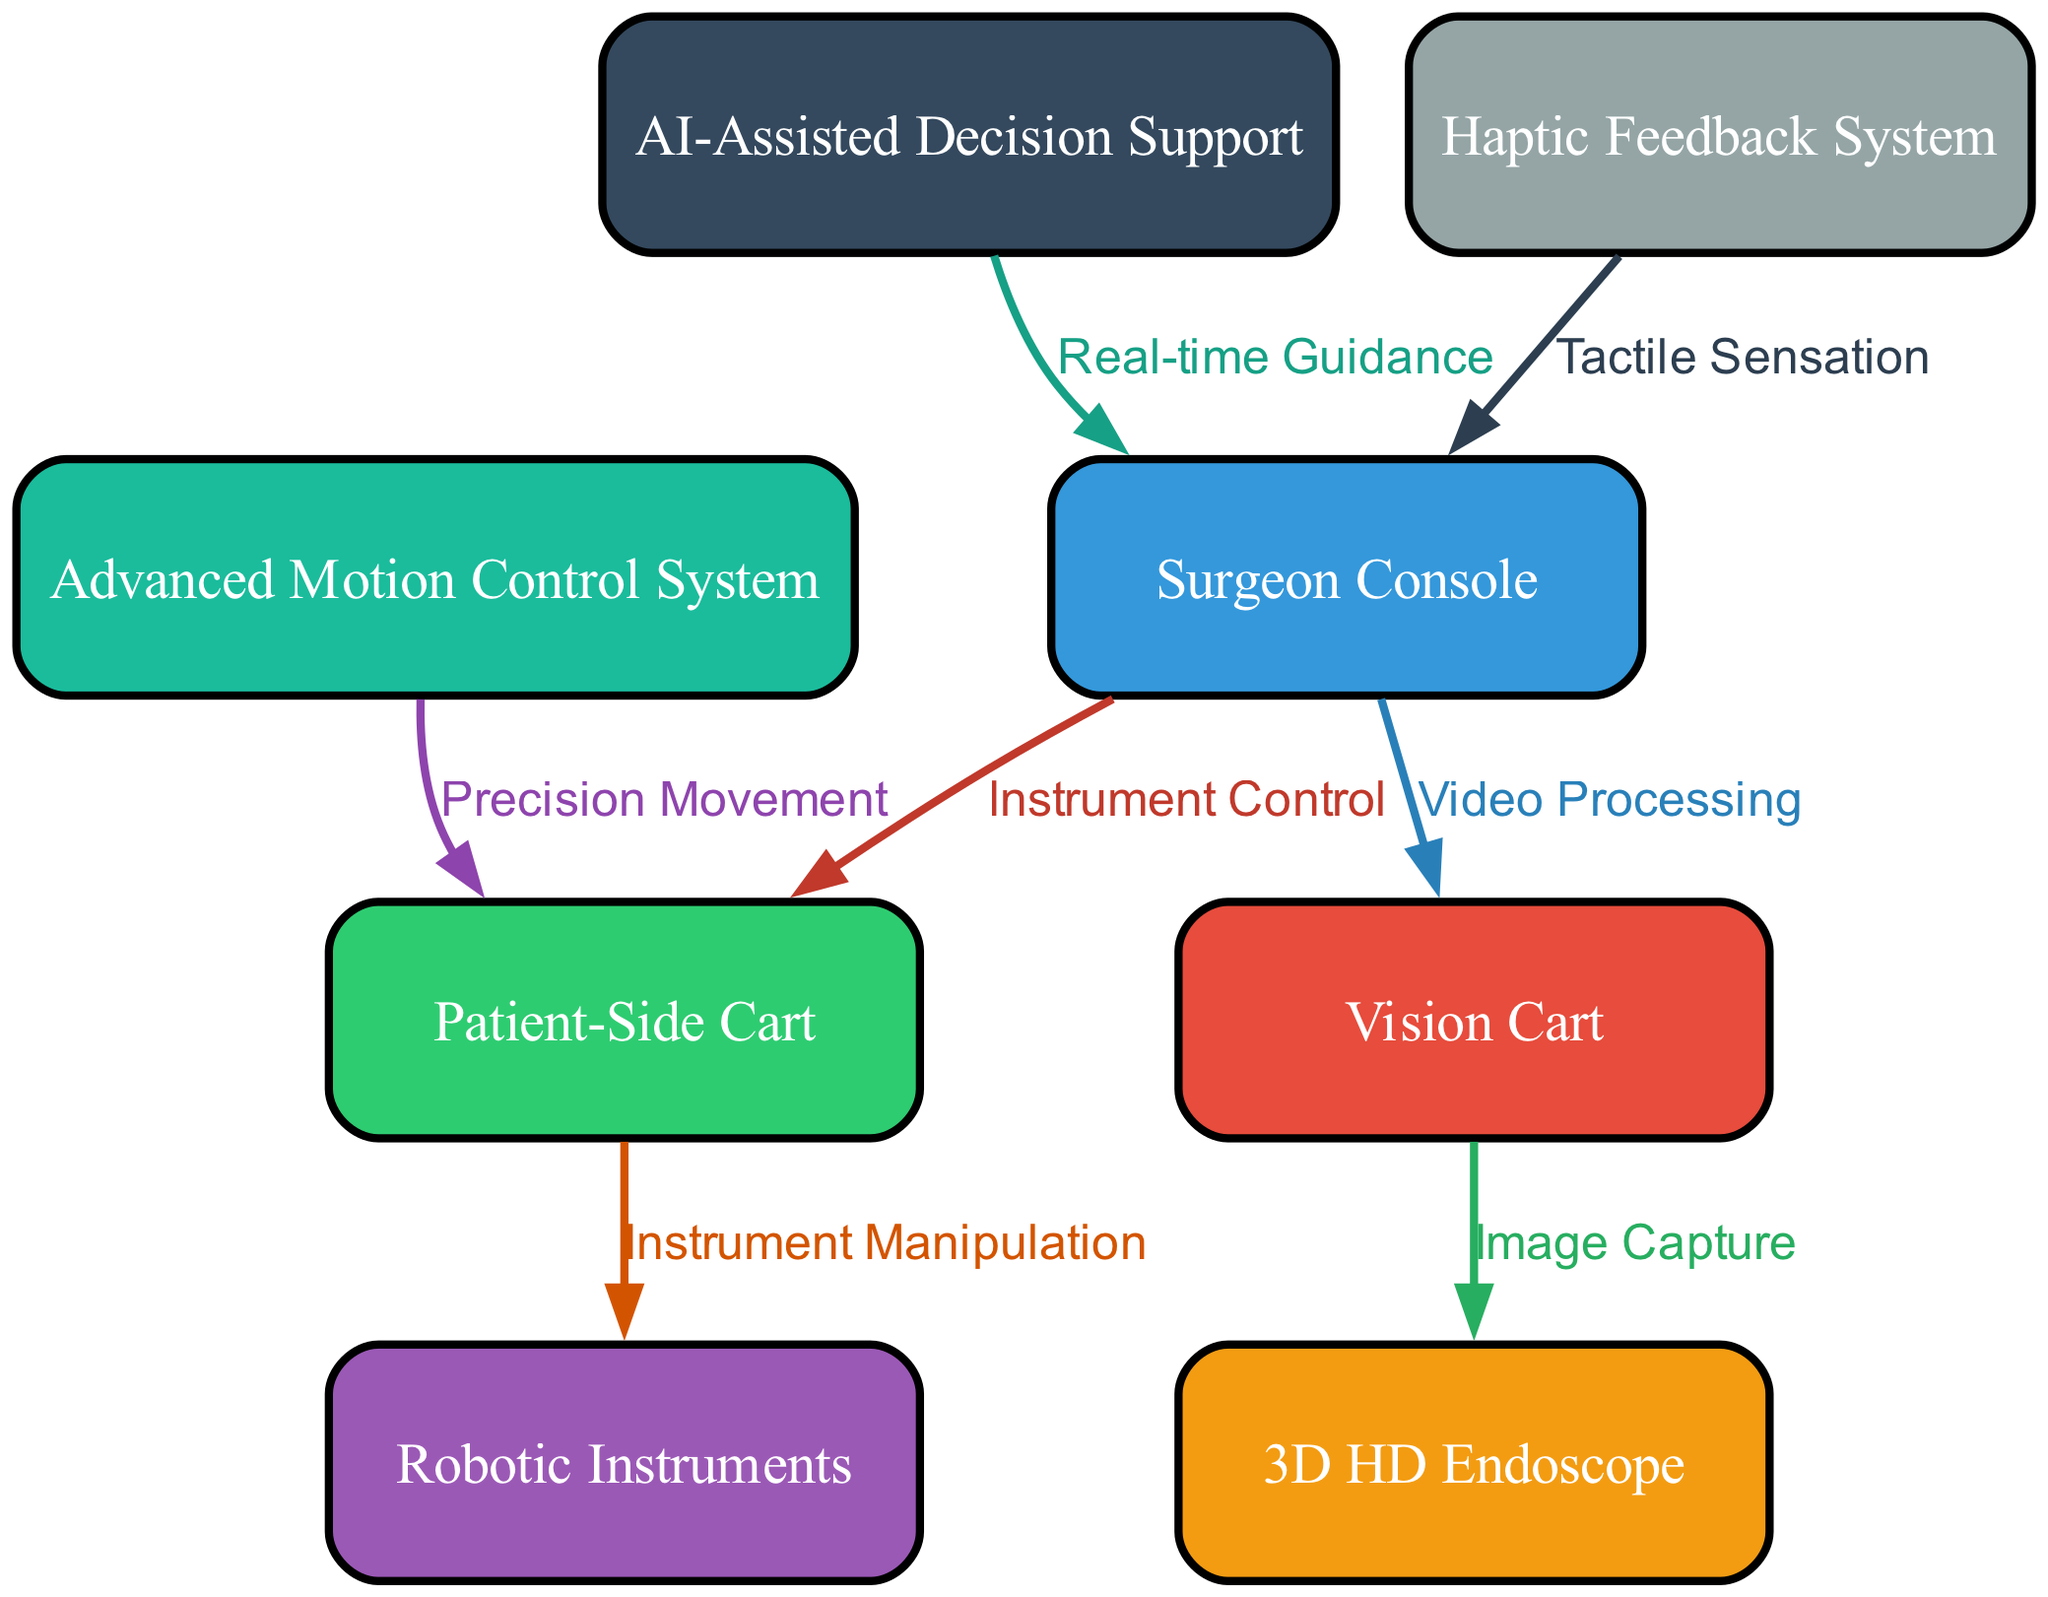What is the total number of nodes in the diagram? The diagram contains eight distinct nodes, which are represented by the surgeon console, vision cart, patient-side cart, 3D HD endoscope, robotic instruments, advanced motion control system, AI-assisted decision support, and haptic feedback system. Counting these gives a total of eight nodes.
Answer: eight Which node is connected to the vision cart? The vision cart has a direct connection to two nodes: the surgeon console (for video processing) and the 3D HD endoscope (for image capture). This indicates that the vision cart serves as an intermediary between these two components.
Answer: 3D HD endoscope What type of feedback is provided by the haptic feedback system? According to the diagram, the haptic feedback system provides tactile sensation to the surgeon console, indicating that it enhances the surgeon's sensory feedback during surgery. This is crucial for performing precise maneuvers with the robotic instruments.
Answer: Tactile sensation From which node does the AI-assisted decision support provide guidance? The AI-assisted decision support node sends real-time guidance to the surgeon console. This indicates that the AI system plays a crucial role in assisting the surgeon with actionable insights during the surgical procedure.
Answer: Surgeon Console What is the role of the advanced motion control system? The advanced motion control system is linked to the patient-side cart for precision movement. It is responsible for ensuring the robotic instruments are moved with high accuracy during the procedure, facilitating safer and more effective surgery outcomes.
Answer: Precision movement How many edges are represented in the diagram? The diagram comprises seven edges. Each edge represents a different type of connection or relationship between the nodes, accurately depicting the interactions within the robotic-assisted minimally invasive surgery system.
Answer: seven What connection does the surgeon console have with the patient-side cart? The surgeon console is connected to the patient-side cart through the instrument control relationship. This connection signifies that commands from the console directly manage the operations of the instruments on the patient-side cart during surgery.
Answer: Instrument Control 